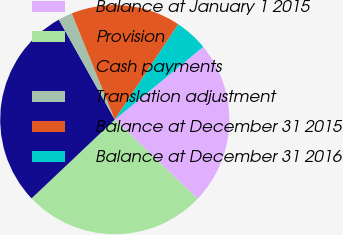Convert chart. <chart><loc_0><loc_0><loc_500><loc_500><pie_chart><fcel>Balance at January 1 2015<fcel>Provision<fcel>Cash payments<fcel>Translation adjustment<fcel>Balance at December 31 2015<fcel>Balance at December 31 2016<nl><fcel>23.1%<fcel>25.79%<fcel>28.94%<fcel>2.0%<fcel>15.47%<fcel>4.69%<nl></chart> 